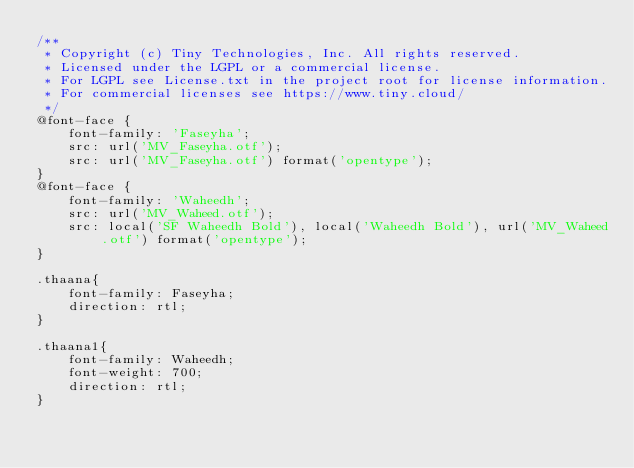<code> <loc_0><loc_0><loc_500><loc_500><_CSS_>/**
 * Copyright (c) Tiny Technologies, Inc. All rights reserved.
 * Licensed under the LGPL or a commercial license.
 * For LGPL see License.txt in the project root for license information.
 * For commercial licenses see https://www.tiny.cloud/
 */
@font-face {
    font-family: 'Faseyha';
    src: url('MV_Faseyha.otf');
    src: url('MV_Faseyha.otf') format('opentype');
}
@font-face {
    font-family: 'Waheedh';
    src: url('MV_Waheed.otf');
    src: local('SF Waheedh Bold'), local('Waheedh Bold'), url('MV_Waheed.otf') format('opentype');
}

.thaana{
    font-family: Faseyha;
    direction: rtl;
}

.thaana1{
    font-family: Waheedh;
    font-weight: 700;
    direction: rtl;
}</code> 